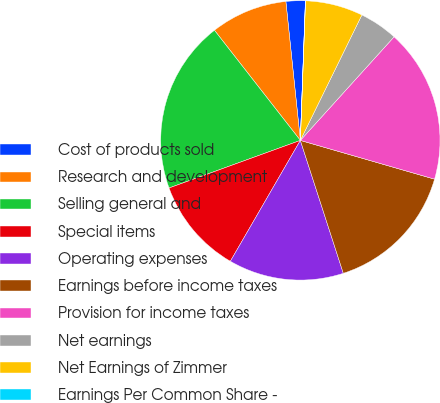Convert chart to OTSL. <chart><loc_0><loc_0><loc_500><loc_500><pie_chart><fcel>Cost of products sold<fcel>Research and development<fcel>Selling general and<fcel>Special items<fcel>Operating expenses<fcel>Earnings before income taxes<fcel>Provision for income taxes<fcel>Net earnings<fcel>Net Earnings of Zimmer<fcel>Earnings Per Common Share -<nl><fcel>2.23%<fcel>8.89%<fcel>19.99%<fcel>11.11%<fcel>13.33%<fcel>15.55%<fcel>17.77%<fcel>4.45%<fcel>6.67%<fcel>0.01%<nl></chart> 